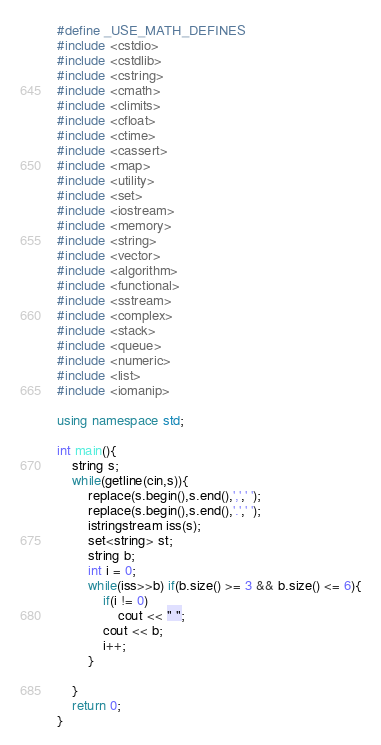Convert code to text. <code><loc_0><loc_0><loc_500><loc_500><_C++_>#define _USE_MATH_DEFINES
#include <cstdio>
#include <cstdlib>
#include <cstring>
#include <cmath>
#include <climits>
#include <cfloat>
#include <ctime>
#include <cassert>
#include <map>
#include <utility>
#include <set>
#include <iostream>
#include <memory>
#include <string>
#include <vector>
#include <algorithm>
#include <functional>
#include <sstream>
#include <complex>
#include <stack>
#include <queue>
#include <numeric>
#include <list>
#include <iomanip>

using namespace std;

int main(){
	string s;
	while(getline(cin,s)){
		replace(s.begin(),s.end(),',',' ');
		replace(s.begin(),s.end(),'.',' ');
		istringstream iss(s);
		set<string> st;
		string b;
		int i = 0;
		while(iss>>b) if(b.size() >= 3 && b.size() <= 6){
			if(i != 0)
				cout << " ";
			cout << b;
			i++;
		}

	}
    return 0;
}</code> 